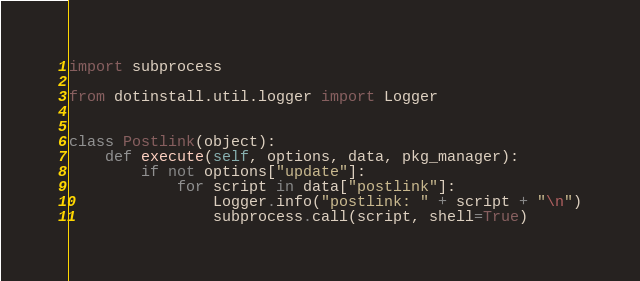<code> <loc_0><loc_0><loc_500><loc_500><_Python_>import subprocess

from dotinstall.util.logger import Logger


class Postlink(object):
    def execute(self, options, data, pkg_manager):
        if not options["update"]:
            for script in data["postlink"]:
                Logger.info("postlink: " + script + "\n")
                subprocess.call(script, shell=True)
</code> 